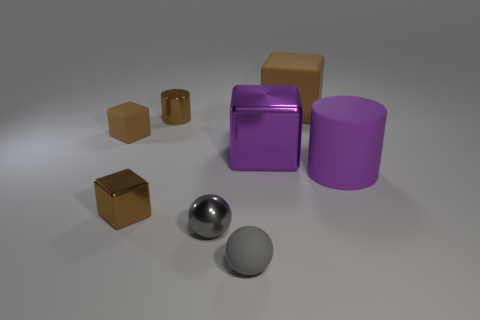Subtract all purple blocks. How many blocks are left? 3 Subtract all purple cylinders. How many cylinders are left? 1 Subtract all balls. How many objects are left? 6 Add 1 tiny brown objects. How many objects exist? 9 Subtract all blue blocks. How many cyan spheres are left? 0 Add 8 small cubes. How many small cubes are left? 10 Add 7 cylinders. How many cylinders exist? 9 Subtract 0 gray blocks. How many objects are left? 8 Subtract 2 cylinders. How many cylinders are left? 0 Subtract all yellow blocks. Subtract all yellow balls. How many blocks are left? 4 